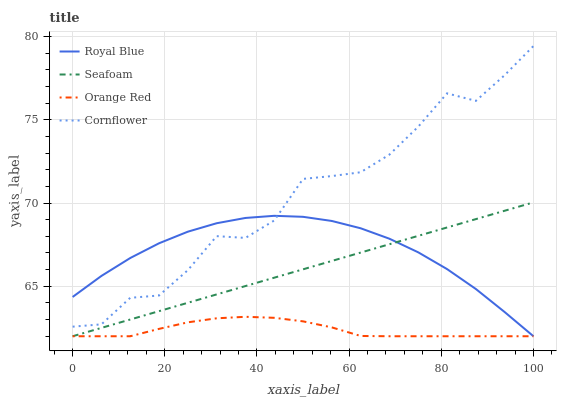Does Orange Red have the minimum area under the curve?
Answer yes or no. Yes. Does Cornflower have the maximum area under the curve?
Answer yes or no. Yes. Does Seafoam have the minimum area under the curve?
Answer yes or no. No. Does Seafoam have the maximum area under the curve?
Answer yes or no. No. Is Seafoam the smoothest?
Answer yes or no. Yes. Is Cornflower the roughest?
Answer yes or no. Yes. Is Cornflower the smoothest?
Answer yes or no. No. Is Seafoam the roughest?
Answer yes or no. No. Does Royal Blue have the lowest value?
Answer yes or no. Yes. Does Cornflower have the lowest value?
Answer yes or no. No. Does Cornflower have the highest value?
Answer yes or no. Yes. Does Seafoam have the highest value?
Answer yes or no. No. Is Seafoam less than Cornflower?
Answer yes or no. Yes. Is Cornflower greater than Orange Red?
Answer yes or no. Yes. Does Orange Red intersect Royal Blue?
Answer yes or no. Yes. Is Orange Red less than Royal Blue?
Answer yes or no. No. Is Orange Red greater than Royal Blue?
Answer yes or no. No. Does Seafoam intersect Cornflower?
Answer yes or no. No. 